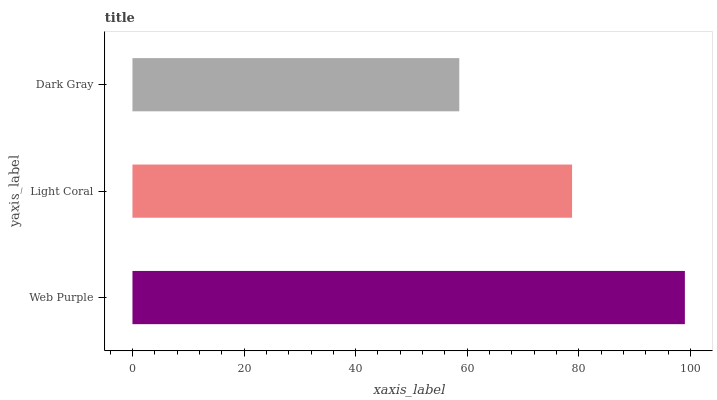Is Dark Gray the minimum?
Answer yes or no. Yes. Is Web Purple the maximum?
Answer yes or no. Yes. Is Light Coral the minimum?
Answer yes or no. No. Is Light Coral the maximum?
Answer yes or no. No. Is Web Purple greater than Light Coral?
Answer yes or no. Yes. Is Light Coral less than Web Purple?
Answer yes or no. Yes. Is Light Coral greater than Web Purple?
Answer yes or no. No. Is Web Purple less than Light Coral?
Answer yes or no. No. Is Light Coral the high median?
Answer yes or no. Yes. Is Light Coral the low median?
Answer yes or no. Yes. Is Dark Gray the high median?
Answer yes or no. No. Is Dark Gray the low median?
Answer yes or no. No. 